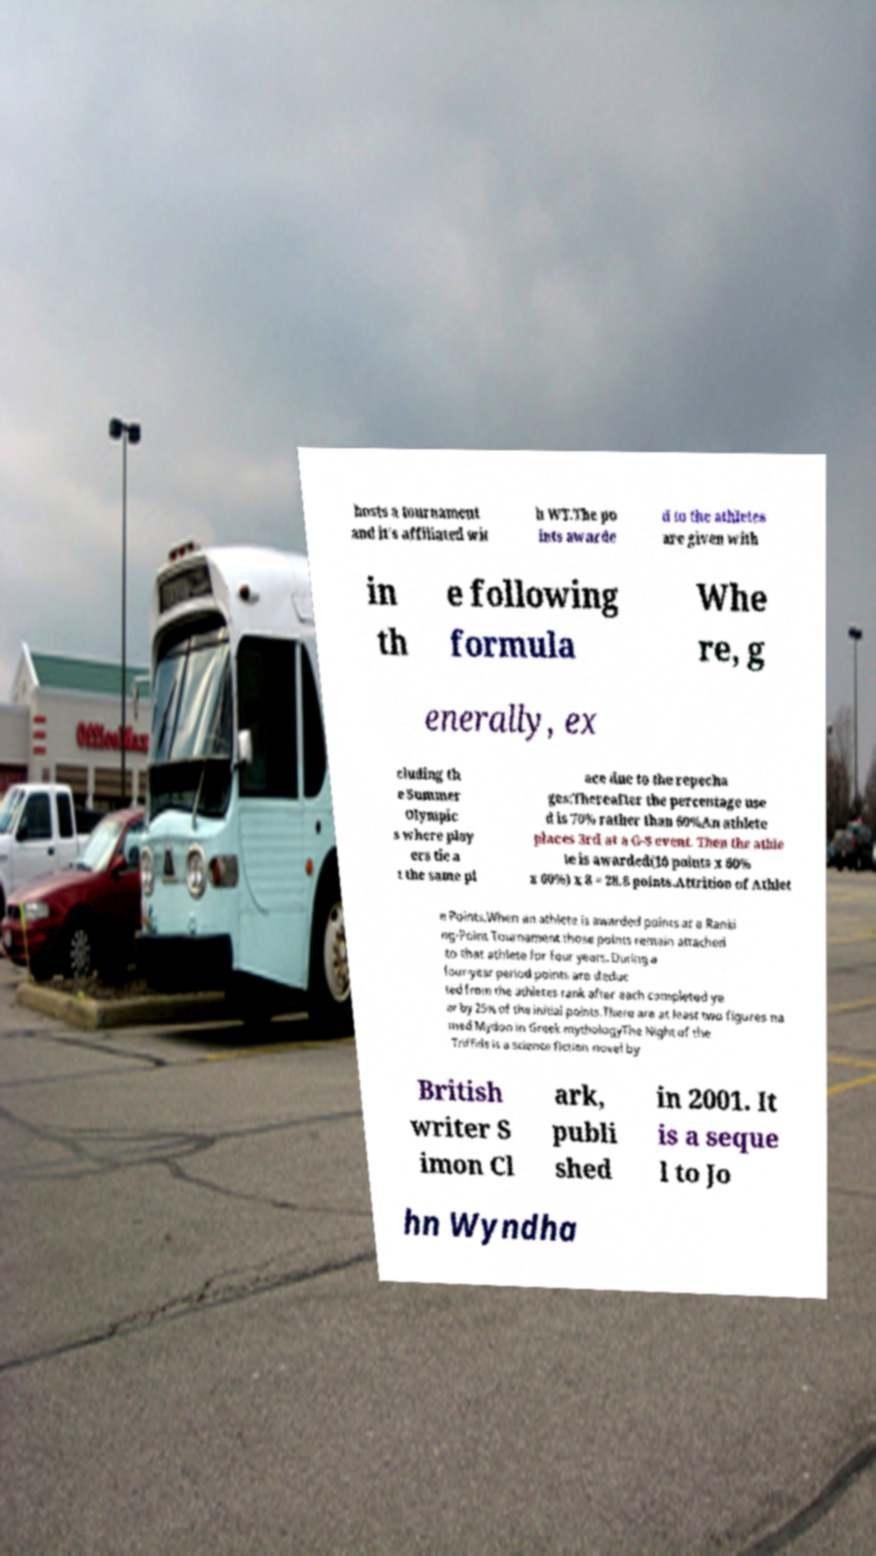Could you assist in decoding the text presented in this image and type it out clearly? hosts a tournament and it's affiliated wit h WT.The po ints awarde d to the athletes are given with in th e following formula Whe re, g enerally, ex cluding th e Summer Olympic s where play ers tie a t the same pl ace due to the repecha ges:Thereafter the percentage use d is 70% rather than 60%An athlete places 3rd at a G-8 event. Then the athle te is awarded(10 points x 60% x 60%) x 8 = 28.8 points.Attrition of Athlet e Points.When an athlete is awarded points at a Ranki ng-Point Tournament those points remain attached to that athlete for four years. During a four-year period points are deduc ted from the athletes rank after each completed ye ar by 25% of the initial points.There are at least two figures na med Mydon in Greek mythologyThe Night of the Triffids is a science fiction novel by British writer S imon Cl ark, publi shed in 2001. It is a seque l to Jo hn Wyndha 